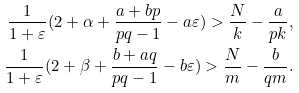Convert formula to latex. <formula><loc_0><loc_0><loc_500><loc_500>\frac { 1 } { 1 + \varepsilon } ( 2 + \alpha + \frac { a + b p } { p q - 1 } - a \varepsilon ) > \frac { N } { k } - \frac { a } { p k } , \\ \frac { 1 } { 1 + \varepsilon } ( 2 + \beta + \frac { b + a q } { p q - 1 } - b \varepsilon ) > \frac { N } { m } - \frac { b } { q m } .</formula> 